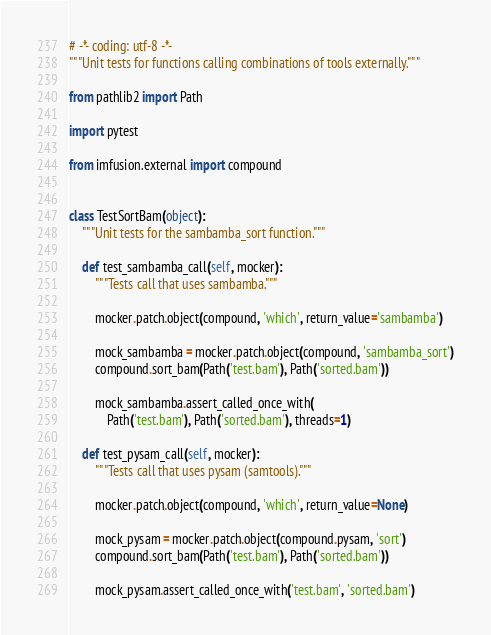Convert code to text. <code><loc_0><loc_0><loc_500><loc_500><_Python_># -*- coding: utf-8 -*-
"""Unit tests for functions calling combinations of tools externally."""

from pathlib2 import Path

import pytest

from imfusion.external import compound


class TestSortBam(object):
    """Unit tests for the sambamba_sort function."""

    def test_sambamba_call(self, mocker):
        """Tests call that uses sambamba."""

        mocker.patch.object(compound, 'which', return_value='sambamba')

        mock_sambamba = mocker.patch.object(compound, 'sambamba_sort')
        compound.sort_bam(Path('test.bam'), Path('sorted.bam'))

        mock_sambamba.assert_called_once_with(
            Path('test.bam'), Path('sorted.bam'), threads=1)

    def test_pysam_call(self, mocker):
        """Tests call that uses pysam (samtools)."""

        mocker.patch.object(compound, 'which', return_value=None)

        mock_pysam = mocker.patch.object(compound.pysam, 'sort')
        compound.sort_bam(Path('test.bam'), Path('sorted.bam'))

        mock_pysam.assert_called_once_with('test.bam', 'sorted.bam')
</code> 